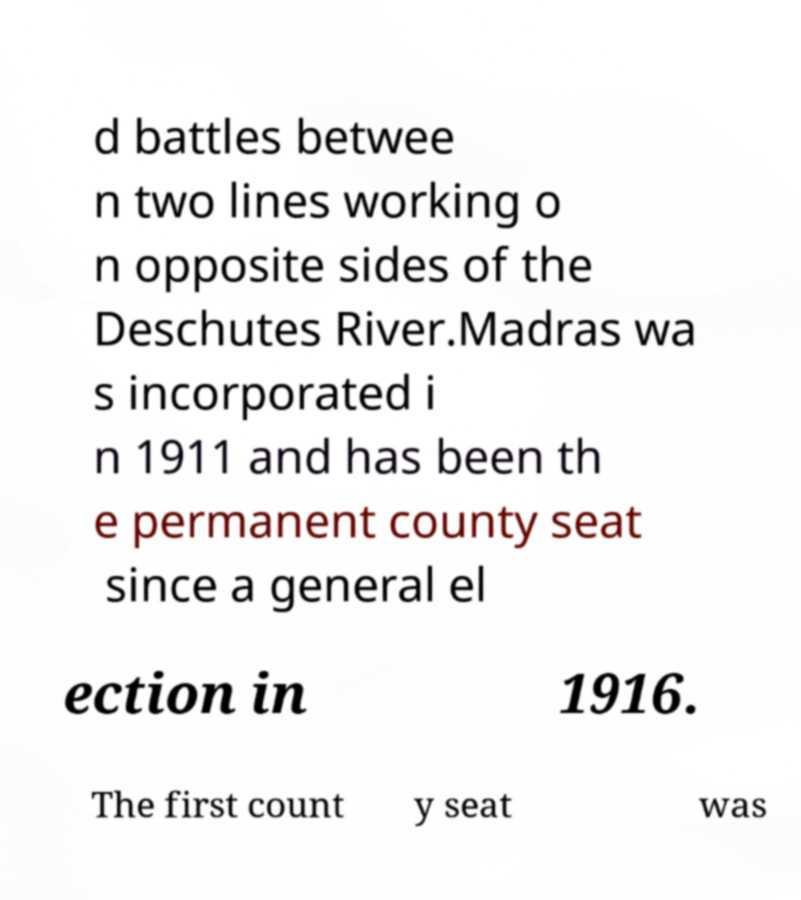What messages or text are displayed in this image? I need them in a readable, typed format. d battles betwee n two lines working o n opposite sides of the Deschutes River.Madras wa s incorporated i n 1911 and has been th e permanent county seat since a general el ection in 1916. The first count y seat was 